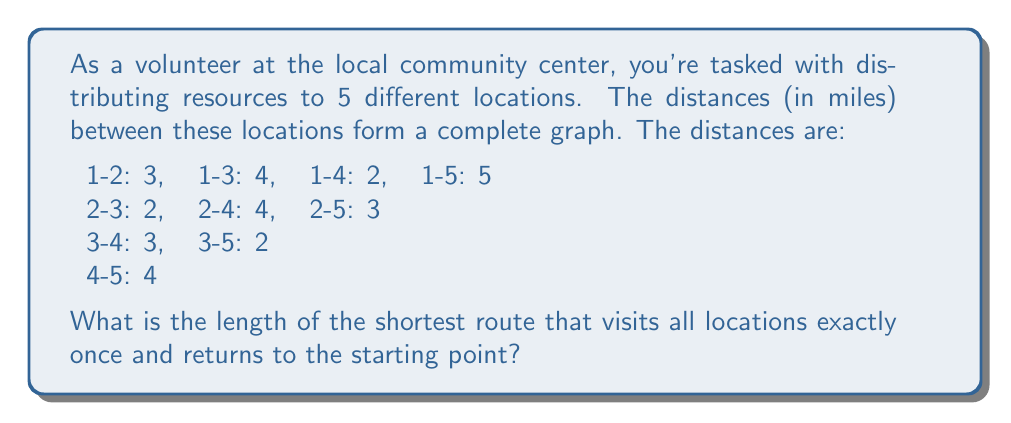Solve this math problem. To solve this problem, we need to find the Hamiltonian cycle with the minimum total distance in the given complete graph. This is known as the Traveling Salesman Problem (TSP).

Step 1: Identify all possible Hamiltonian cycles.
There are $(5-1)!/2 = 12$ possible cycles, as we can start at any point and go in either direction.

Step 2: Calculate the distance for each cycle.
Let's represent each cycle as a sequence of numbers, where 1 is our starting and ending point.

1. 1-2-3-4-5-1: $3 + 2 + 3 + 4 + 5 = 17$
2. 1-2-3-5-4-1: $3 + 2 + 2 + 4 + 2 = 13$
3. 1-2-4-3-5-1: $3 + 4 + 3 + 2 + 5 = 17$
4. 1-2-4-5-3-1: $3 + 4 + 4 + 2 + 4 = 17$
5. 1-2-5-3-4-1: $3 + 3 + 2 + 3 + 2 = 13$
6. 1-2-5-4-3-1: $3 + 3 + 4 + 3 + 4 = 17$
7. 1-3-2-4-5-1: $4 + 2 + 4 + 4 + 5 = 19$
8. 1-3-2-5-4-1: $4 + 2 + 3 + 4 + 2 = 15$
9. 1-3-4-2-5-1: $4 + 3 + 4 + 3 + 5 = 19$
10. 1-3-4-5-2-1: $4 + 3 + 4 + 3 + 3 = 17$
11. 1-3-5-2-4-1: $4 + 2 + 3 + 4 + 2 = 15$
12. 1-3-5-4-2-1: $4 + 2 + 4 + 4 + 3 = 17$

Step 3: Identify the minimum distance.
The minimum distance is 13 miles, which occurs in two cycles: 1-2-3-5-4-1 and 1-2-5-3-4-1.

Therefore, the shortest route that visits all locations exactly once and returns to the starting point is 13 miles long.
Answer: 13 miles 